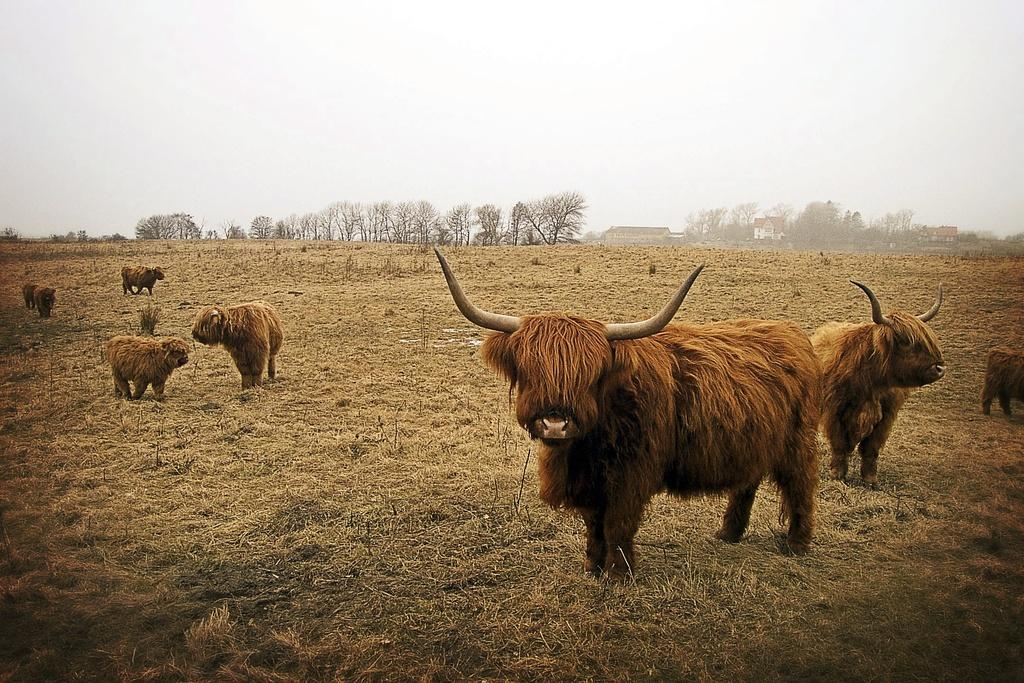What type of animals are on both sides of the image? There are yaks on both the left and right sides of the image. What is the surface on which the yaks are standing? The yaks are standing on the ground. What can be seen in the background of the image? There are trees, buildings, and houses in the background of the image. What is visible in the sky in the image? There are clouds in the sky. Can you tell me how many bananas are being held by the yaks in the image? There are no bananas present in the image; the yaks are not holding any. What type of need is being fulfilled by the yaks in the image? The image does not depict any specific need being fulfilled by the yaks. 